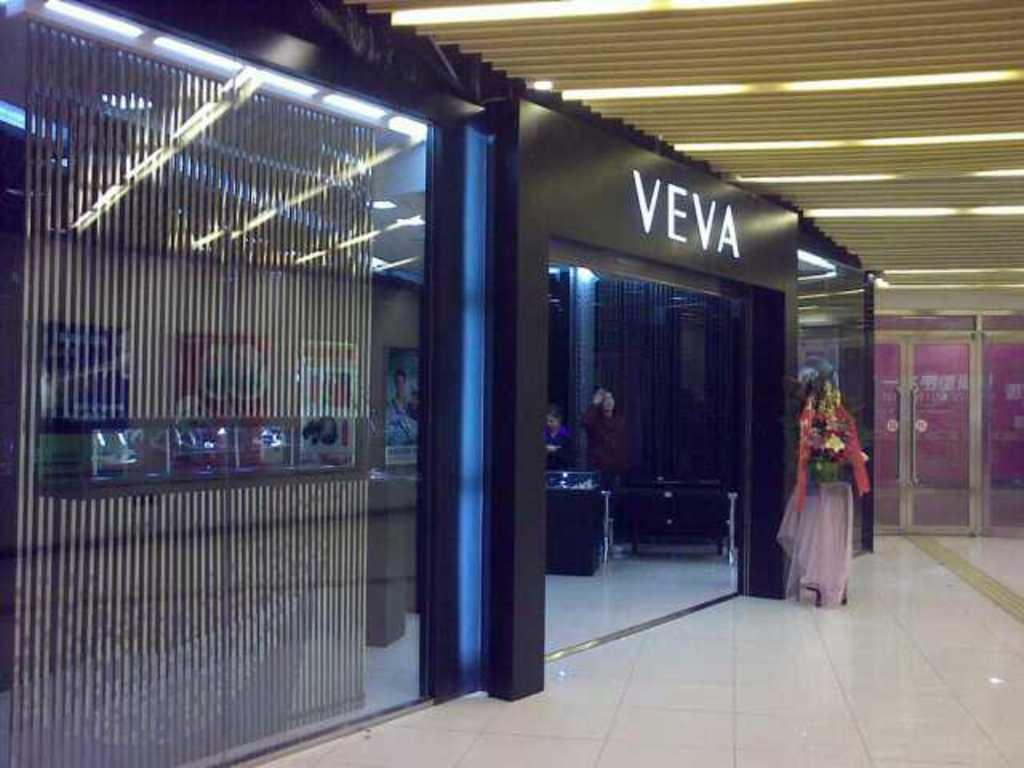Describe this image in one or two sentences. In the center of the image there is a store and we can see people standing in the store. On the right there is a stand and we can see a bouquet placed on the stand. At the top there are lights. 